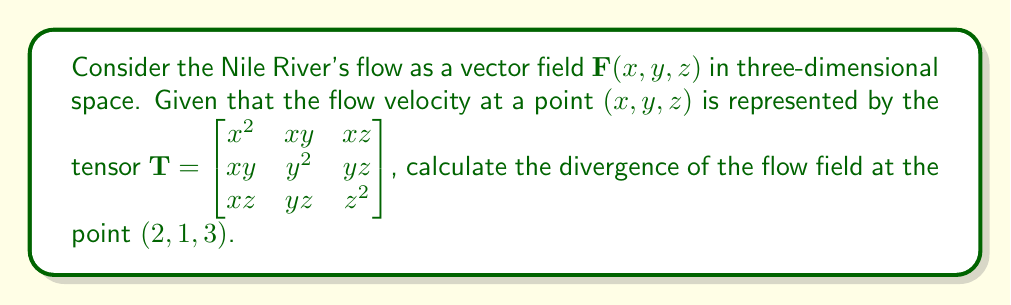Could you help me with this problem? To solve this problem, we need to follow these steps:

1) The divergence of a vector field $\mathbf{F}(x, y, z)$ is given by:

   $$\nabla \cdot \mathbf{F} = \frac{\partial F_x}{\partial x} + \frac{\partial F_y}{\partial y} + \frac{\partial F_z}{\partial z}$$

2) In this case, our vector field is represented by the tensor $\mathbf{T}$. We need to extract the components of the vector field from the diagonal of the tensor:

   $F_x = x^2$
   $F_y = y^2$
   $F_z = z^2$

3) Now, we calculate the partial derivatives:

   $\frac{\partial F_x}{\partial x} = \frac{\partial (x^2)}{\partial x} = 2x$
   
   $\frac{\partial F_y}{\partial y} = \frac{\partial (y^2)}{\partial y} = 2y$
   
   $\frac{\partial F_z}{\partial z} = \frac{\partial (z^2)}{\partial z} = 2z$

4) Substituting these into the divergence formula:

   $$\nabla \cdot \mathbf{F} = 2x + 2y + 2z$$

5) Finally, we evaluate this at the point $(2, 1, 3)$:

   $$\nabla \cdot \mathbf{F}|_{(2,1,3)} = 2(2) + 2(1) + 2(3) = 4 + 2 + 6 = 12$$
Answer: 12 